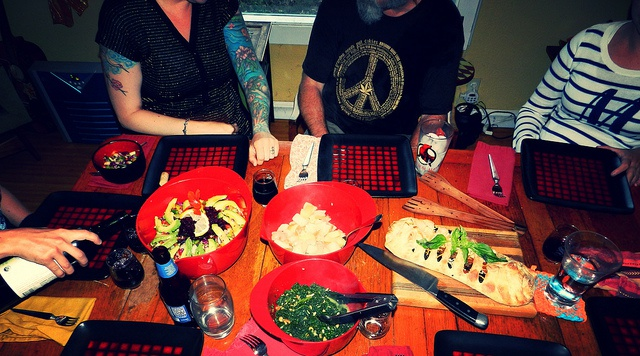Describe the objects in this image and their specific colors. I can see dining table in black, red, and maroon tones, people in black, tan, teal, and gray tones, people in black, gray, brown, and maroon tones, people in black, darkgray, navy, and teal tones, and bowl in black, red, and khaki tones in this image. 